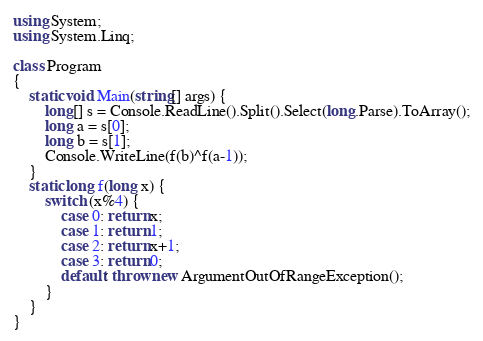<code> <loc_0><loc_0><loc_500><loc_500><_C#_>using System;
using System.Linq;

class Program
{
    static void Main(string[] args) {
        long[] s = Console.ReadLine().Split().Select(long.Parse).ToArray();
        long a = s[0];
        long b = s[1];
        Console.WriteLine(f(b)^f(a-1));
    }
    static long f(long x) {
        switch (x%4) {
            case 0: return x;
            case 1: return 1;
            case 2: return x+1;
            case 3: return 0;
            default: throw new ArgumentOutOfRangeException();
        }
    }
}</code> 